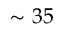<formula> <loc_0><loc_0><loc_500><loc_500>\sim 3 5</formula> 